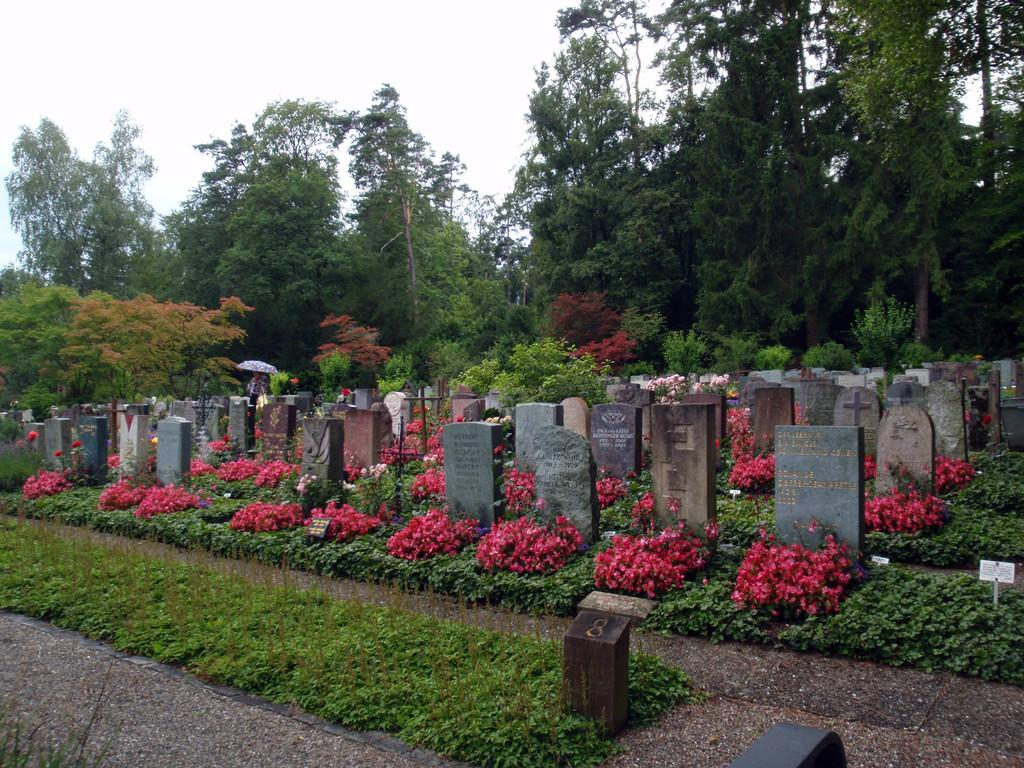What type of location is depicted in the image? The image contains cemeteries. What can be seen growing in the cemeteries? There are flowers, trees, and plants in the image. What type of ring can be seen on the vest of the person in the image? There is no person wearing a vest in the image, and therefore no ring can be seen. 